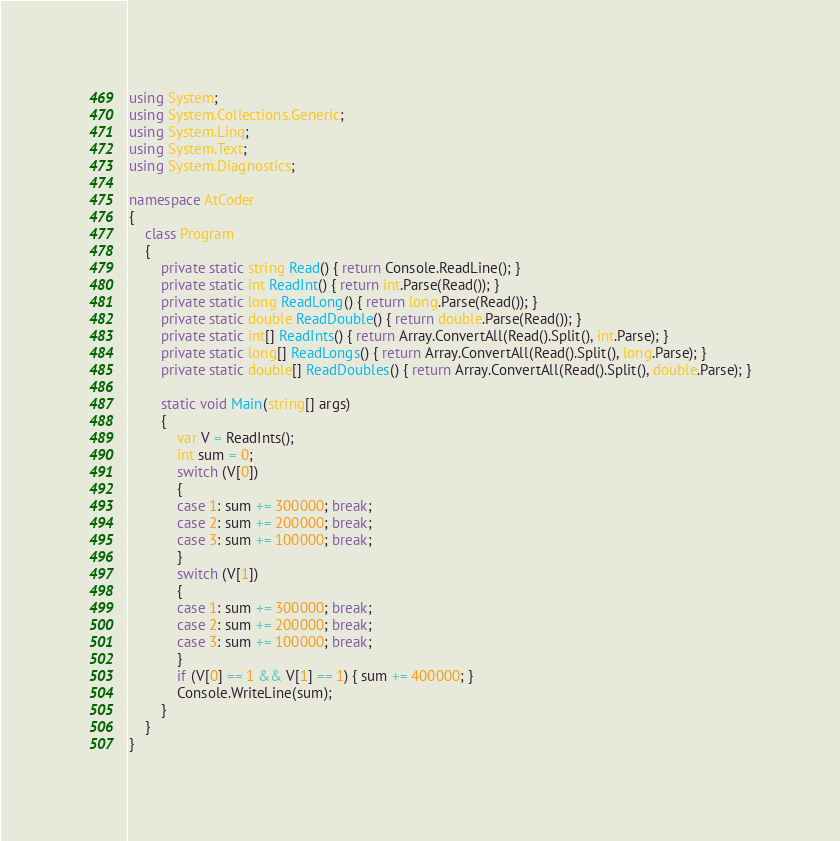Convert code to text. <code><loc_0><loc_0><loc_500><loc_500><_C#_>using System;
using System.Collections.Generic;
using System.Linq;
using System.Text;
using System.Diagnostics;

namespace AtCoder
{
    class Program
    {
        private static string Read() { return Console.ReadLine(); }
        private static int ReadInt() { return int.Parse(Read()); }
        private static long ReadLong() { return long.Parse(Read()); }
        private static double ReadDouble() { return double.Parse(Read()); }
        private static int[] ReadInts() { return Array.ConvertAll(Read().Split(), int.Parse); }
        private static long[] ReadLongs() { return Array.ConvertAll(Read().Split(), long.Parse); }
        private static double[] ReadDoubles() { return Array.ConvertAll(Read().Split(), double.Parse); }

        static void Main(string[] args)
        {
            var V = ReadInts();
            int sum = 0;
            switch (V[0])
            {
            case 1: sum += 300000; break;
            case 2: sum += 200000; break;
            case 3: sum += 100000; break;
            }
            switch (V[1])
            {
            case 1: sum += 300000; break;
            case 2: sum += 200000; break;
            case 3: sum += 100000; break;
            }
            if (V[0] == 1 && V[1] == 1) { sum += 400000; }
            Console.WriteLine(sum);
        }
    }
}
</code> 